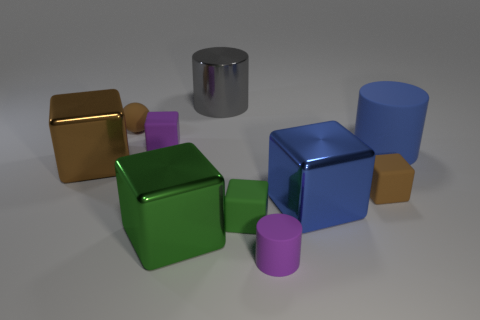What material is the big thing that is the same color as the large rubber cylinder?
Offer a very short reply. Metal. There is a large object that is to the right of the big blue metallic block; is its color the same as the tiny rubber cylinder?
Provide a short and direct response. No. How many objects are large cubes that are to the right of the tiny purple matte cylinder or tiny balls?
Your answer should be compact. 2. Is the number of small green things to the right of the large blue matte thing greater than the number of balls that are to the right of the brown rubber sphere?
Give a very brief answer. No. Does the ball have the same material as the small green object?
Your response must be concise. Yes. There is a shiny thing that is left of the tiny purple cylinder and to the right of the large green metallic block; what shape is it?
Keep it short and to the point. Cylinder. The green thing that is made of the same material as the tiny cylinder is what shape?
Give a very brief answer. Cube. Are any red matte cylinders visible?
Provide a succinct answer. No. Are there any tiny purple rubber objects left of the small brown matte thing that is left of the purple block?
Offer a very short reply. No. There is another big object that is the same shape as the large gray metal thing; what material is it?
Offer a terse response. Rubber. 